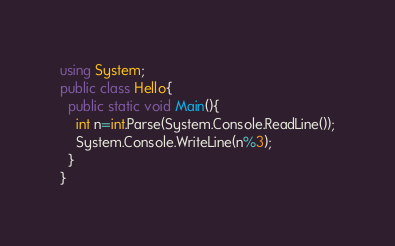<code> <loc_0><loc_0><loc_500><loc_500><_C#_>using System;
public class Hello{
  public static void Main(){
    int n=int.Parse(System.Console.ReadLine());
    System.Console.WriteLine(n%3);
  }
}</code> 